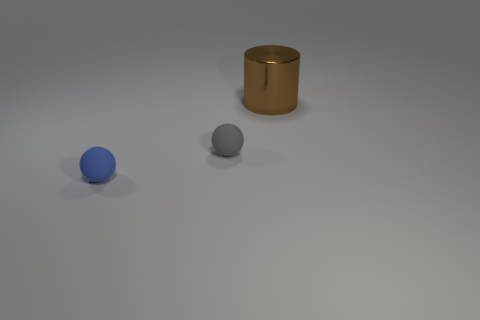Subtract all gray spheres. How many spheres are left? 1 Subtract all cylinders. How many objects are left? 2 Subtract all red cylinders. Subtract all cyan cubes. How many cylinders are left? 1 Subtract all purple cylinders. How many green balls are left? 0 Subtract all tiny gray balls. Subtract all red matte spheres. How many objects are left? 2 Add 3 gray rubber objects. How many gray rubber objects are left? 4 Add 3 brown blocks. How many brown blocks exist? 3 Add 1 big balls. How many objects exist? 4 Subtract 1 blue balls. How many objects are left? 2 Subtract 2 balls. How many balls are left? 0 